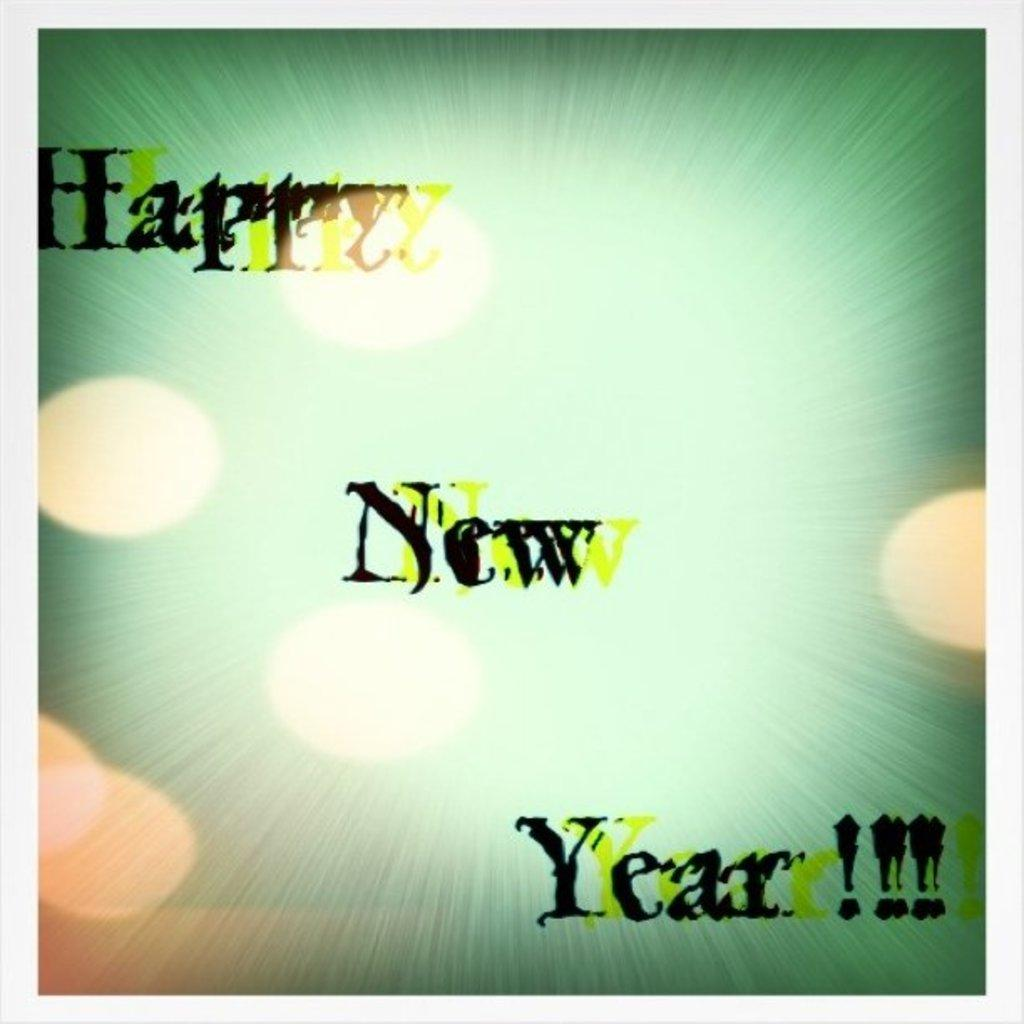Provide a one-sentence caption for the provided image. A graphic featuring the phrase "Happy New Year!!!" has a green background. 